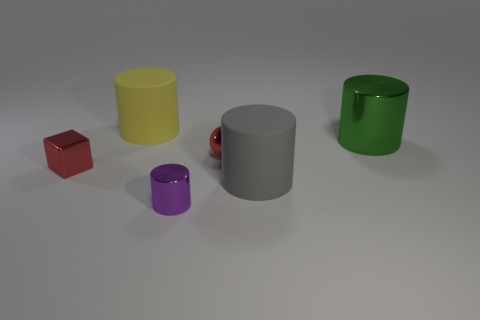Describe the lighting setup that might be used to achieve the shadows in the image. The shadows in the image suggest a single light source from above, casting consistent angled shadows. The shadows extend to the right, indicating the light source is likely positioned towards the upper left. 